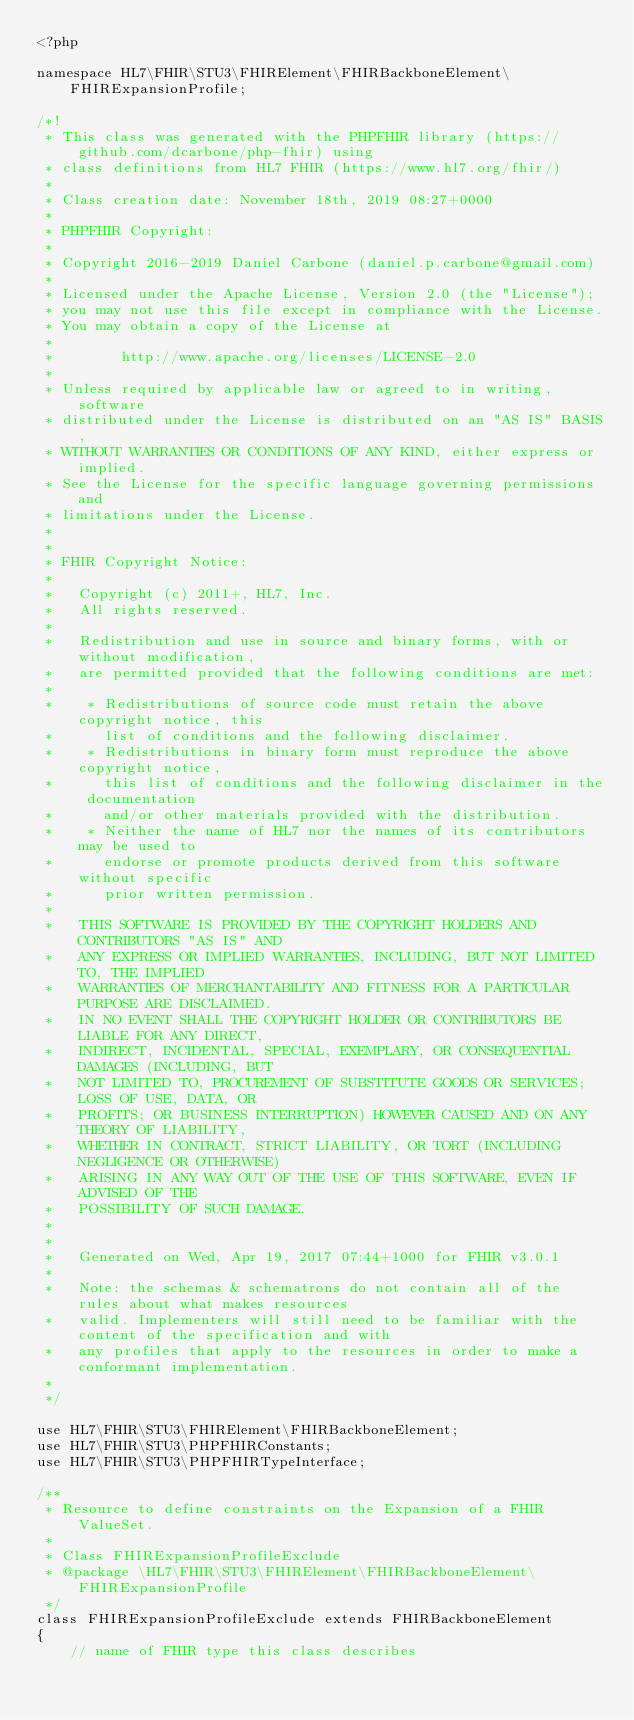<code> <loc_0><loc_0><loc_500><loc_500><_PHP_><?php

namespace HL7\FHIR\STU3\FHIRElement\FHIRBackboneElement\FHIRExpansionProfile;

/*!
 * This class was generated with the PHPFHIR library (https://github.com/dcarbone/php-fhir) using
 * class definitions from HL7 FHIR (https://www.hl7.org/fhir/)
 * 
 * Class creation date: November 18th, 2019 08:27+0000
 * 
 * PHPFHIR Copyright:
 * 
 * Copyright 2016-2019 Daniel Carbone (daniel.p.carbone@gmail.com)
 * 
 * Licensed under the Apache License, Version 2.0 (the "License");
 * you may not use this file except in compliance with the License.
 * You may obtain a copy of the License at
 * 
 *        http://www.apache.org/licenses/LICENSE-2.0
 * 
 * Unless required by applicable law or agreed to in writing, software
 * distributed under the License is distributed on an "AS IS" BASIS,
 * WITHOUT WARRANTIES OR CONDITIONS OF ANY KIND, either express or implied.
 * See the License for the specific language governing permissions and
 * limitations under the License.
 * 
 *
 * FHIR Copyright Notice:
 *
 *   Copyright (c) 2011+, HL7, Inc.
 *   All rights reserved.
 * 
 *   Redistribution and use in source and binary forms, with or without modification,
 *   are permitted provided that the following conditions are met:
 * 
 *    * Redistributions of source code must retain the above copyright notice, this
 *      list of conditions and the following disclaimer.
 *    * Redistributions in binary form must reproduce the above copyright notice,
 *      this list of conditions and the following disclaimer in the documentation
 *      and/or other materials provided with the distribution.
 *    * Neither the name of HL7 nor the names of its contributors may be used to
 *      endorse or promote products derived from this software without specific
 *      prior written permission.
 * 
 *   THIS SOFTWARE IS PROVIDED BY THE COPYRIGHT HOLDERS AND CONTRIBUTORS "AS IS" AND
 *   ANY EXPRESS OR IMPLIED WARRANTIES, INCLUDING, BUT NOT LIMITED TO, THE IMPLIED
 *   WARRANTIES OF MERCHANTABILITY AND FITNESS FOR A PARTICULAR PURPOSE ARE DISCLAIMED.
 *   IN NO EVENT SHALL THE COPYRIGHT HOLDER OR CONTRIBUTORS BE LIABLE FOR ANY DIRECT,
 *   INDIRECT, INCIDENTAL, SPECIAL, EXEMPLARY, OR CONSEQUENTIAL DAMAGES (INCLUDING, BUT
 *   NOT LIMITED TO, PROCUREMENT OF SUBSTITUTE GOODS OR SERVICES; LOSS OF USE, DATA, OR
 *   PROFITS; OR BUSINESS INTERRUPTION) HOWEVER CAUSED AND ON ANY THEORY OF LIABILITY,
 *   WHETHER IN CONTRACT, STRICT LIABILITY, OR TORT (INCLUDING NEGLIGENCE OR OTHERWISE)
 *   ARISING IN ANY WAY OUT OF THE USE OF THIS SOFTWARE, EVEN IF ADVISED OF THE
 *   POSSIBILITY OF SUCH DAMAGE.
 * 
 * 
 *   Generated on Wed, Apr 19, 2017 07:44+1000 for FHIR v3.0.1
 * 
 *   Note: the schemas & schematrons do not contain all of the rules about what makes resources
 *   valid. Implementers will still need to be familiar with the content of the specification and with
 *   any profiles that apply to the resources in order to make a conformant implementation.
 * 
 */

use HL7\FHIR\STU3\FHIRElement\FHIRBackboneElement;
use HL7\FHIR\STU3\PHPFHIRConstants;
use HL7\FHIR\STU3\PHPFHIRTypeInterface;

/**
 * Resource to define constraints on the Expansion of a FHIR ValueSet.
 *
 * Class FHIRExpansionProfileExclude
 * @package \HL7\FHIR\STU3\FHIRElement\FHIRBackboneElement\FHIRExpansionProfile
 */
class FHIRExpansionProfileExclude extends FHIRBackboneElement
{
    // name of FHIR type this class describes</code> 